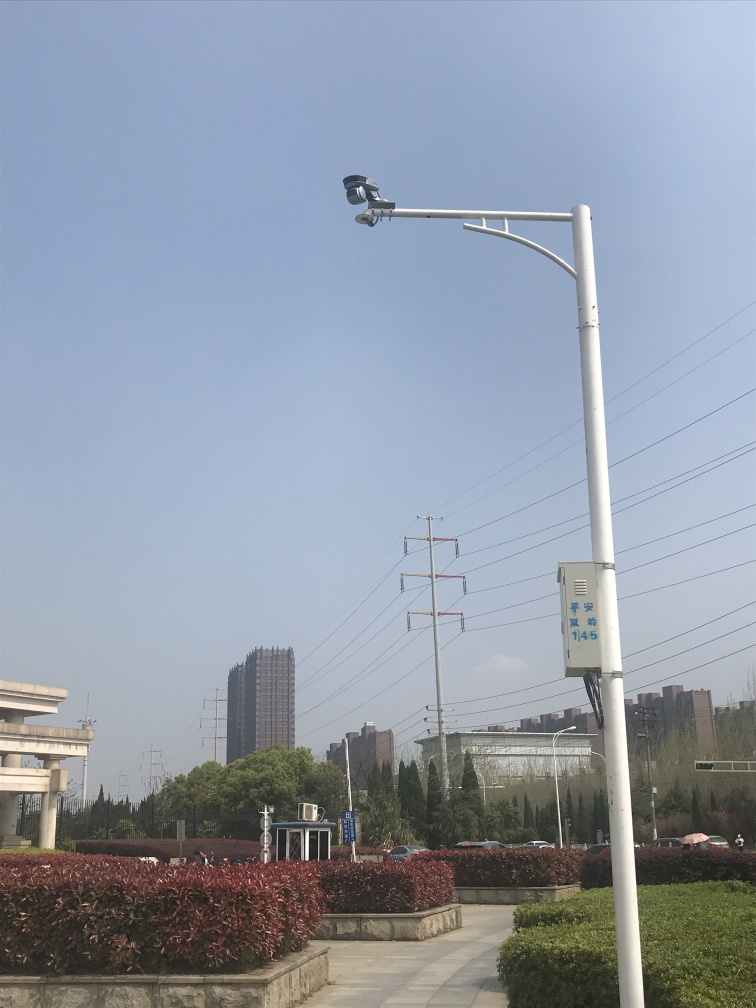Are there any quality issues with this image? The image is clear with good visibility, but it suffers from overexposure in the sky, which causes a loss of detail in that area. The composition might also seem unbalanced due to the dominating presence of the sky and a lamp post in the foreground, which draws attention away from the other elements. 